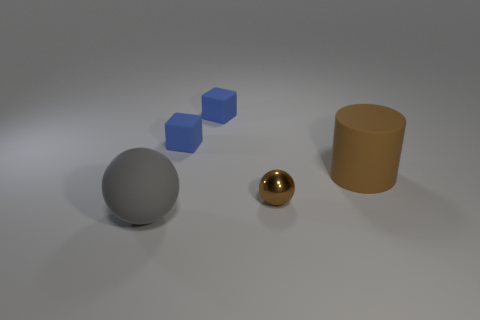Are there any other things that are made of the same material as the tiny brown sphere?
Offer a very short reply. No. What number of rubber objects are the same size as the gray sphere?
Your answer should be compact. 1. Are there fewer brown rubber cylinders on the left side of the metal thing than blue blocks left of the brown cylinder?
Provide a succinct answer. Yes. How big is the brown metal object in front of the big thing that is behind the brown object that is in front of the brown cylinder?
Offer a very short reply. Small. There is a object that is on the left side of the tiny brown sphere and in front of the matte cylinder; what size is it?
Make the answer very short. Large. There is a large thing that is right of the big gray matte object to the left of the tiny metal object; what is its shape?
Keep it short and to the point. Cylinder. Are there any other things of the same color as the metallic ball?
Provide a succinct answer. Yes. The tiny shiny thing behind the gray matte ball has what shape?
Give a very brief answer. Sphere. The object that is both in front of the big brown rubber thing and on the right side of the big gray matte thing has what shape?
Your answer should be compact. Sphere. How many gray objects are large balls or shiny cylinders?
Provide a succinct answer. 1. 